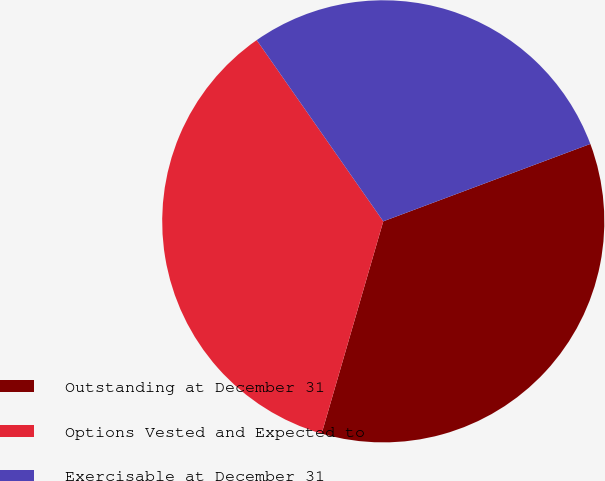<chart> <loc_0><loc_0><loc_500><loc_500><pie_chart><fcel>Outstanding at December 31<fcel>Options Vested and Expected to<fcel>Exercisable at December 31<nl><fcel>35.19%<fcel>35.8%<fcel>29.01%<nl></chart> 